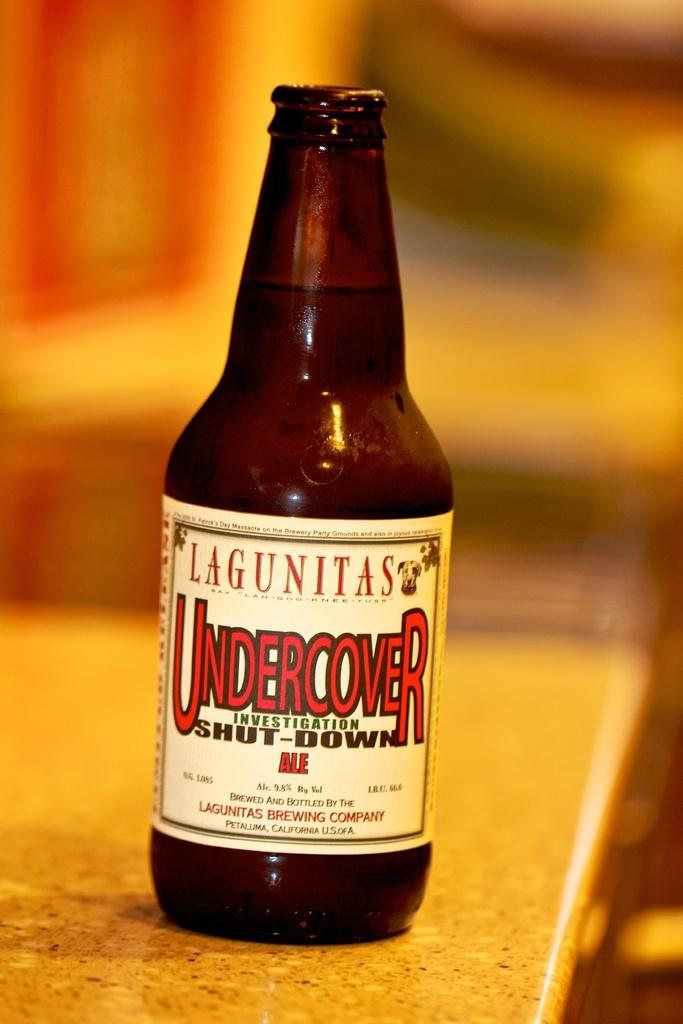<image>
Provide a brief description of the given image. A bottle of alcohol that is brewed by Lagunitas brewing Company is on the counter top. 